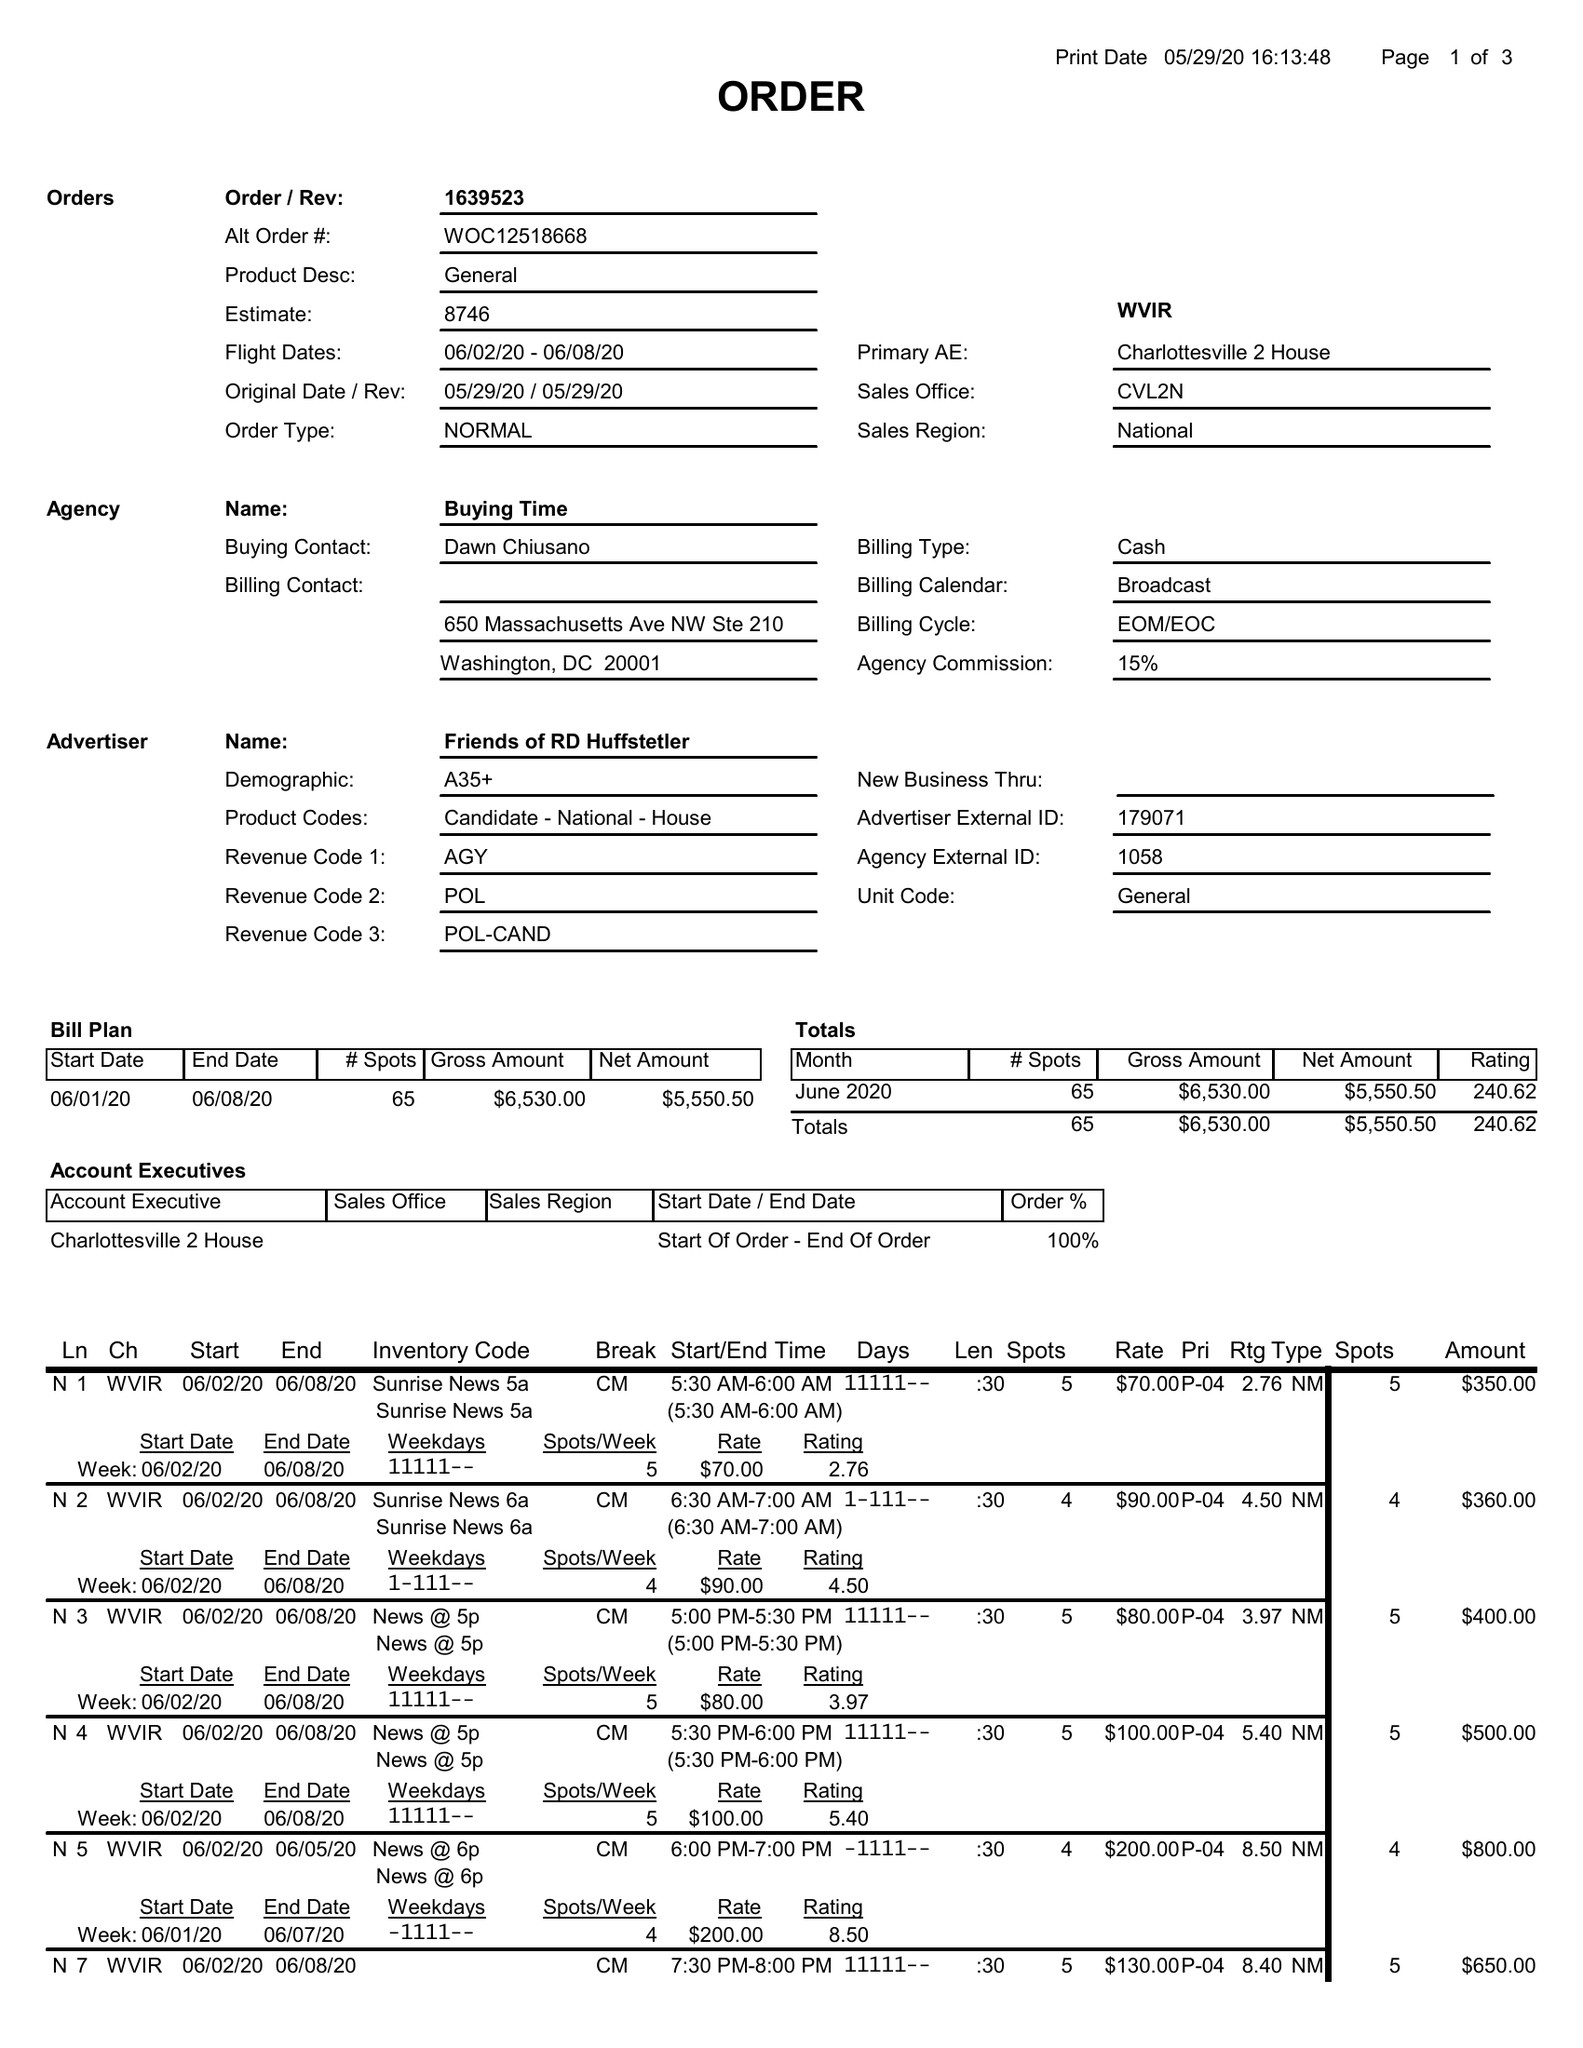What is the value for the contract_num?
Answer the question using a single word or phrase. 1639523 